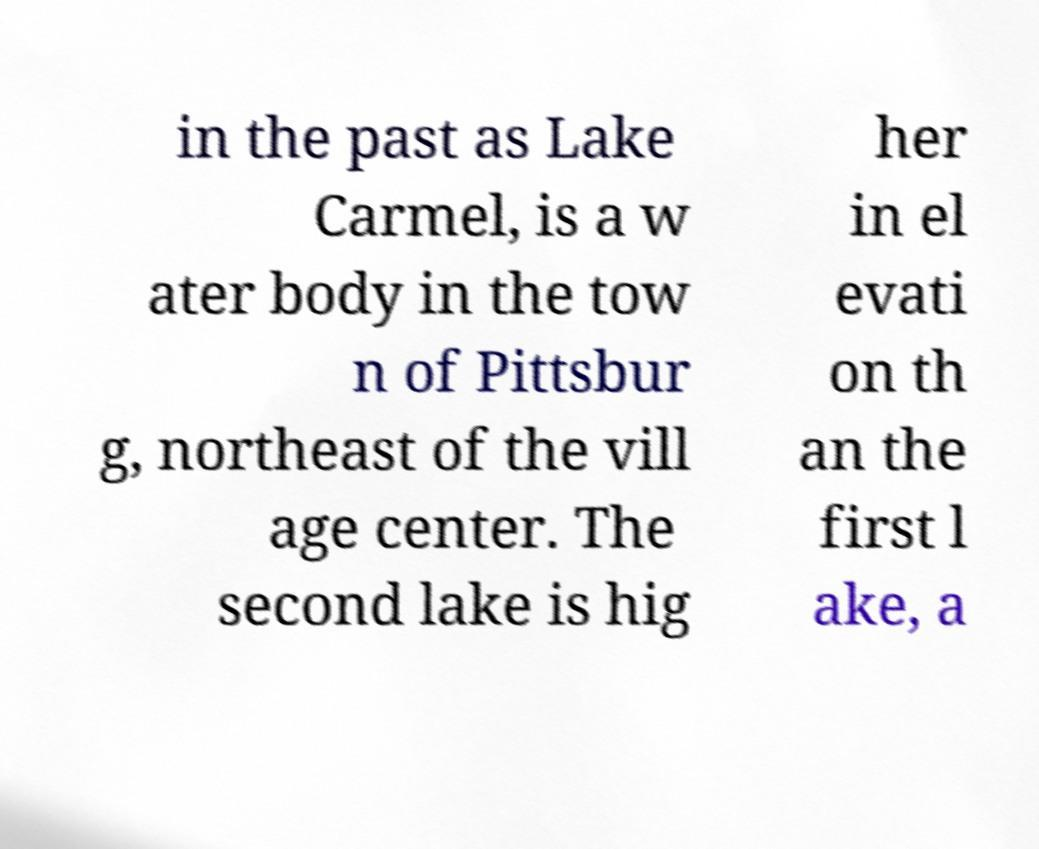Could you extract and type out the text from this image? in the past as Lake Carmel, is a w ater body in the tow n of Pittsbur g, northeast of the vill age center. The second lake is hig her in el evati on th an the first l ake, a 